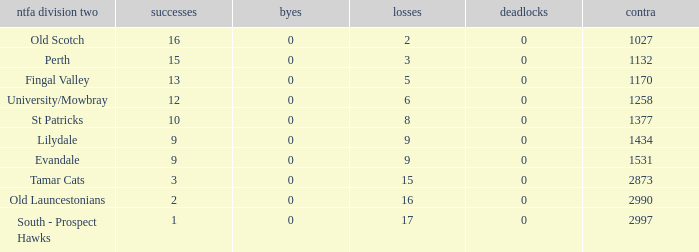What is the lowest number of draws of the team with 9 wins and less than 0 byes? None. 